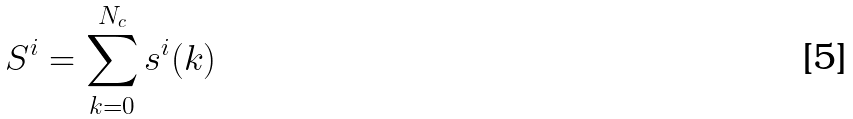Convert formula to latex. <formula><loc_0><loc_0><loc_500><loc_500>S ^ { i } = \sum _ { k = 0 } ^ { N _ { c } } s ^ { i } ( k )</formula> 